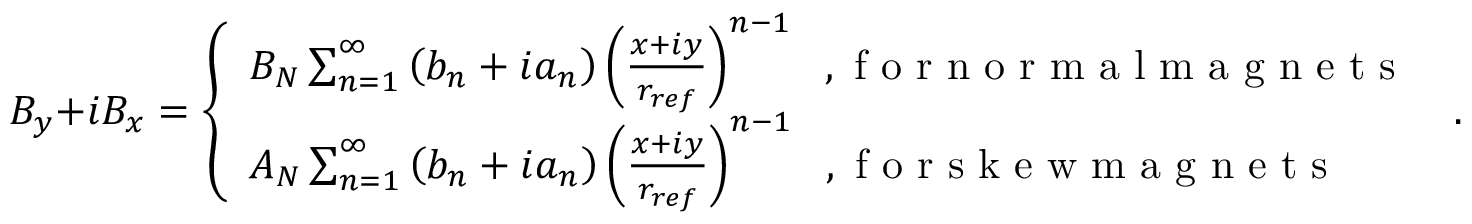<formula> <loc_0><loc_0><loc_500><loc_500>B _ { y } + i B _ { x } = \left \{ \begin{array} { l l } { B _ { N } \sum _ { n = 1 } ^ { \infty } \left ( b _ { n } + i a _ { n } \right ) \left ( \frac { x + i y } { r _ { r e f } } \right ) ^ { n - 1 } \, , f o r n o r m a l m a g n e t s } \\ { A _ { N } \sum _ { n = 1 } ^ { \infty } \left ( b _ { n } + i a _ { n } \right ) \left ( \frac { x + i y } { r _ { r e f } } \right ) ^ { n - 1 } \, , f o r s k e w m a g n e t s } \end{array} \, .</formula> 